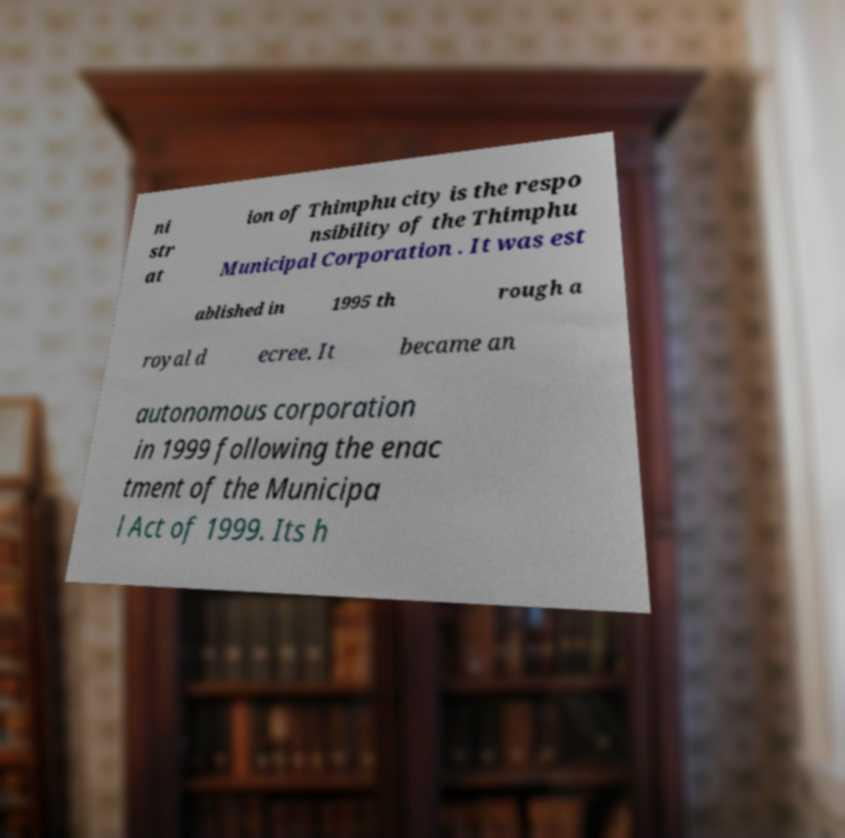I need the written content from this picture converted into text. Can you do that? ni str at ion of Thimphu city is the respo nsibility of the Thimphu Municipal Corporation . It was est ablished in 1995 th rough a royal d ecree. It became an autonomous corporation in 1999 following the enac tment of the Municipa l Act of 1999. Its h 